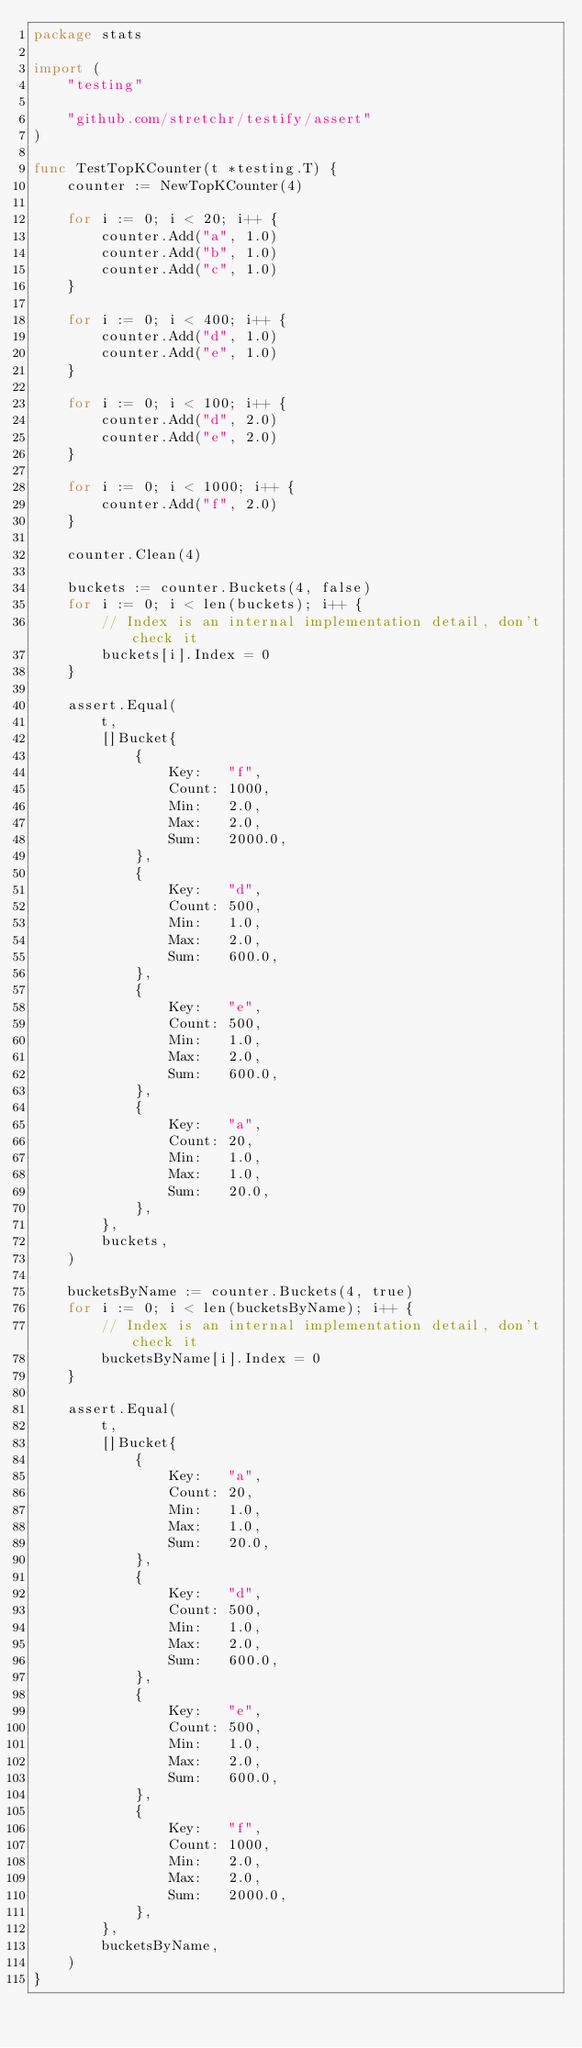<code> <loc_0><loc_0><loc_500><loc_500><_Go_>package stats

import (
	"testing"

	"github.com/stretchr/testify/assert"
)

func TestTopKCounter(t *testing.T) {
	counter := NewTopKCounter(4)

	for i := 0; i < 20; i++ {
		counter.Add("a", 1.0)
		counter.Add("b", 1.0)
		counter.Add("c", 1.0)
	}

	for i := 0; i < 400; i++ {
		counter.Add("d", 1.0)
		counter.Add("e", 1.0)
	}

	for i := 0; i < 100; i++ {
		counter.Add("d", 2.0)
		counter.Add("e", 2.0)
	}

	for i := 0; i < 1000; i++ {
		counter.Add("f", 2.0)
	}

	counter.Clean(4)

	buckets := counter.Buckets(4, false)
	for i := 0; i < len(buckets); i++ {
		// Index is an internal implementation detail, don't check it
		buckets[i].Index = 0
	}

	assert.Equal(
		t,
		[]Bucket{
			{
				Key:   "f",
				Count: 1000,
				Min:   2.0,
				Max:   2.0,
				Sum:   2000.0,
			},
			{
				Key:   "d",
				Count: 500,
				Min:   1.0,
				Max:   2.0,
				Sum:   600.0,
			},
			{
				Key:   "e",
				Count: 500,
				Min:   1.0,
				Max:   2.0,
				Sum:   600.0,
			},
			{
				Key:   "a",
				Count: 20,
				Min:   1.0,
				Max:   1.0,
				Sum:   20.0,
			},
		},
		buckets,
	)

	bucketsByName := counter.Buckets(4, true)
	for i := 0; i < len(bucketsByName); i++ {
		// Index is an internal implementation detail, don't check it
		bucketsByName[i].Index = 0
	}

	assert.Equal(
		t,
		[]Bucket{
			{
				Key:   "a",
				Count: 20,
				Min:   1.0,
				Max:   1.0,
				Sum:   20.0,
			},
			{
				Key:   "d",
				Count: 500,
				Min:   1.0,
				Max:   2.0,
				Sum:   600.0,
			},
			{
				Key:   "e",
				Count: 500,
				Min:   1.0,
				Max:   2.0,
				Sum:   600.0,
			},
			{
				Key:   "f",
				Count: 1000,
				Min:   2.0,
				Max:   2.0,
				Sum:   2000.0,
			},
		},
		bucketsByName,
	)
}
</code> 